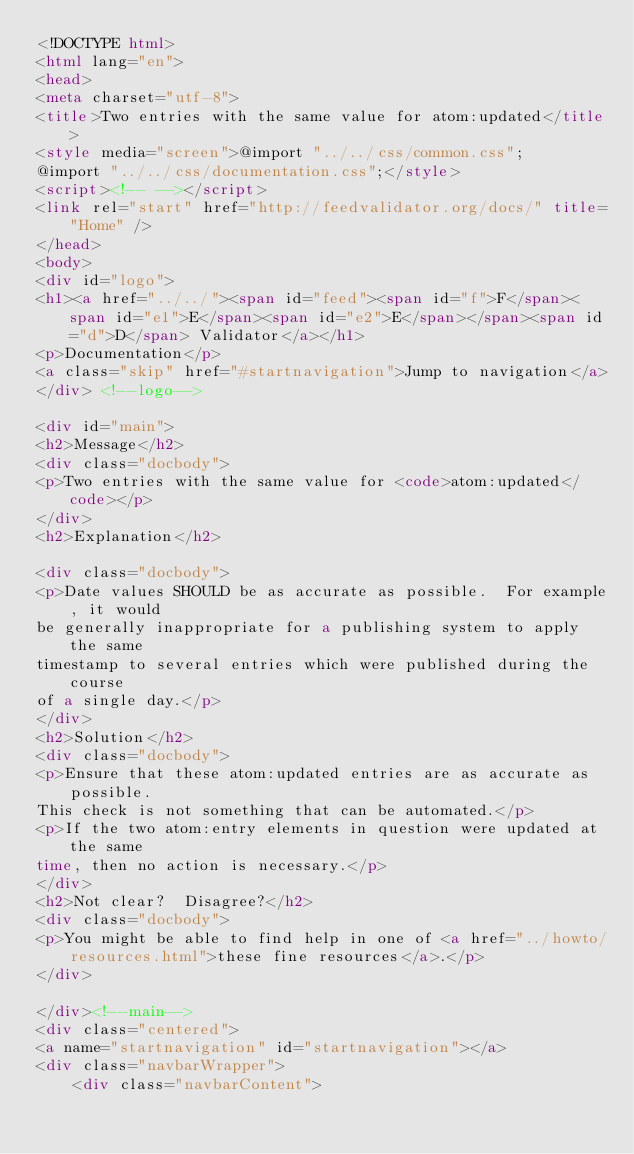<code> <loc_0><loc_0><loc_500><loc_500><_HTML_><!DOCTYPE html>
<html lang="en">
<head>
<meta charset="utf-8">
<title>Two entries with the same value for atom:updated</title>
<style media="screen">@import "../../css/common.css";
@import "../../css/documentation.css";</style>
<script><!-- --></script>
<link rel="start" href="http://feedvalidator.org/docs/" title="Home" />
</head>
<body>
<div id="logo">
<h1><a href="../../"><span id="feed"><span id="f">F</span><span id="e1">E</span><span id="e2">E</span></span><span id="d">D</span> Validator</a></h1>
<p>Documentation</p>
<a class="skip" href="#startnavigation">Jump to navigation</a>
</div> <!--logo-->

<div id="main">
<h2>Message</h2>
<div class="docbody">
<p>Two entries with the same value for <code>atom:updated</code></p>
</div>
<h2>Explanation</h2>

<div class="docbody">
<p>Date values SHOULD be as accurate as possible.  For example, it would
be generally inappropriate for a publishing system to apply the same
timestamp to several entries which were published during the course
of a single day.</p>
</div>
<h2>Solution</h2>
<div class="docbody">
<p>Ensure that these atom:updated entries are as accurate as possible.
This check is not something that can be automated.</p>
<p>If the two atom:entry elements in question were updated at the same
time, then no action is necessary.</p>
</div>
<h2>Not clear?  Disagree?</h2>
<div class="docbody">
<p>You might be able to find help in one of <a href="../howto/resources.html">these fine resources</a>.</p>
</div>

</div><!--main-->
<div class="centered">
<a name="startnavigation" id="startnavigation"></a>
<div class="navbarWrapper">
    <div class="navbarContent"></code> 